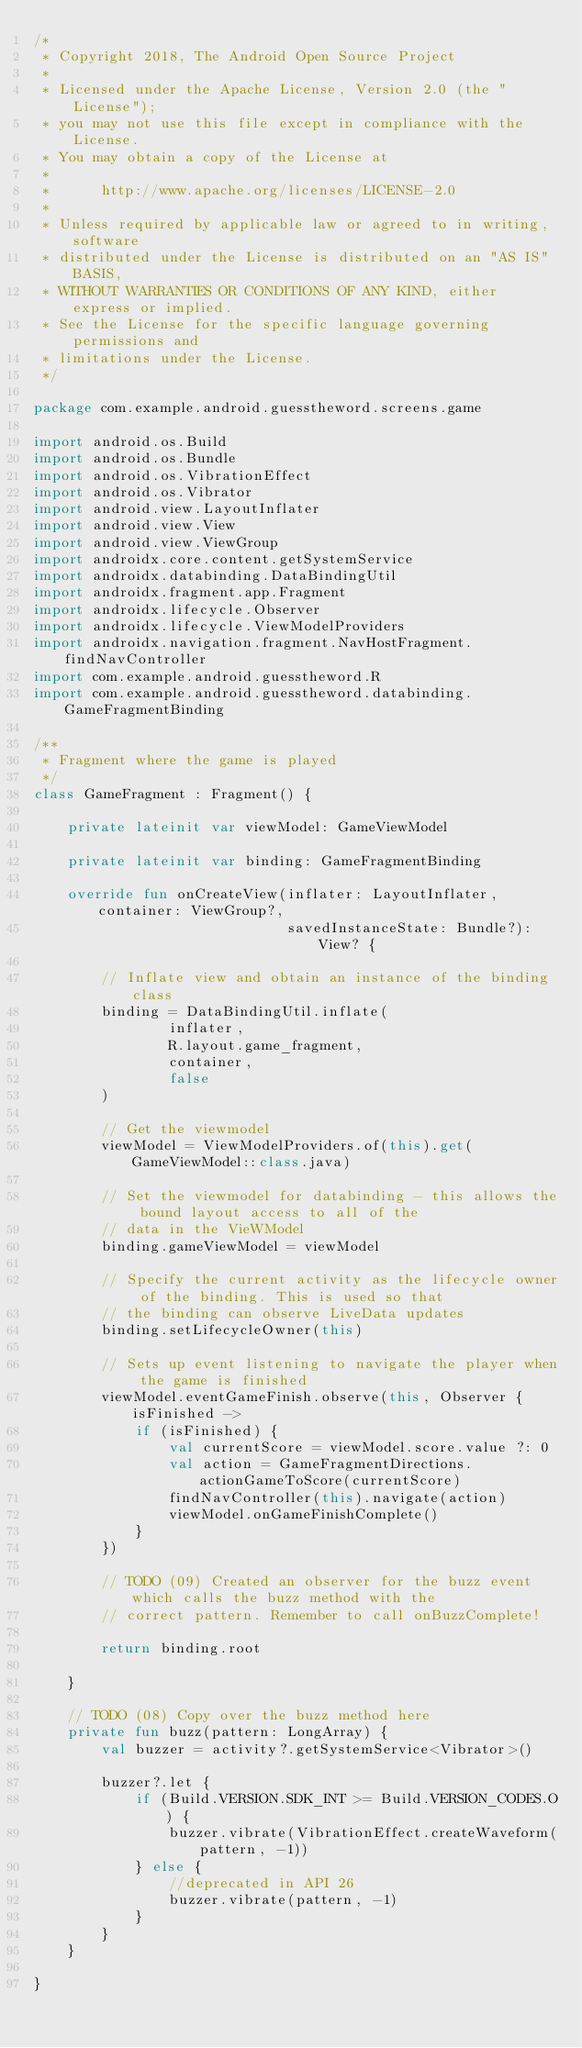<code> <loc_0><loc_0><loc_500><loc_500><_Kotlin_>/*
 * Copyright 2018, The Android Open Source Project
 *
 * Licensed under the Apache License, Version 2.0 (the "License");
 * you may not use this file except in compliance with the License.
 * You may obtain a copy of the License at
 *
 *      http://www.apache.org/licenses/LICENSE-2.0
 *
 * Unless required by applicable law or agreed to in writing, software
 * distributed under the License is distributed on an "AS IS" BASIS,
 * WITHOUT WARRANTIES OR CONDITIONS OF ANY KIND, either express or implied.
 * See the License for the specific language governing permissions and
 * limitations under the License.
 */

package com.example.android.guesstheword.screens.game

import android.os.Build
import android.os.Bundle
import android.os.VibrationEffect
import android.os.Vibrator
import android.view.LayoutInflater
import android.view.View
import android.view.ViewGroup
import androidx.core.content.getSystemService
import androidx.databinding.DataBindingUtil
import androidx.fragment.app.Fragment
import androidx.lifecycle.Observer
import androidx.lifecycle.ViewModelProviders
import androidx.navigation.fragment.NavHostFragment.findNavController
import com.example.android.guesstheword.R
import com.example.android.guesstheword.databinding.GameFragmentBinding

/**
 * Fragment where the game is played
 */
class GameFragment : Fragment() {

    private lateinit var viewModel: GameViewModel

    private lateinit var binding: GameFragmentBinding

    override fun onCreateView(inflater: LayoutInflater, container: ViewGroup?,
                              savedInstanceState: Bundle?): View? {

        // Inflate view and obtain an instance of the binding class
        binding = DataBindingUtil.inflate(
                inflater,
                R.layout.game_fragment,
                container,
                false
        )

        // Get the viewmodel
        viewModel = ViewModelProviders.of(this).get(GameViewModel::class.java)

        // Set the viewmodel for databinding - this allows the bound layout access to all of the
        // data in the VieWModel
        binding.gameViewModel = viewModel

        // Specify the current activity as the lifecycle owner of the binding. This is used so that
        // the binding can observe LiveData updates
        binding.setLifecycleOwner(this)

        // Sets up event listening to navigate the player when the game is finished
        viewModel.eventGameFinish.observe(this, Observer { isFinished ->
            if (isFinished) {
                val currentScore = viewModel.score.value ?: 0
                val action = GameFragmentDirections.actionGameToScore(currentScore)
                findNavController(this).navigate(action)
                viewModel.onGameFinishComplete()
            }
        })

        // TODO (09) Created an observer for the buzz event which calls the buzz method with the
        // correct pattern. Remember to call onBuzzComplete!

        return binding.root

    }

    // TODO (08) Copy over the buzz method here
    private fun buzz(pattern: LongArray) {
        val buzzer = activity?.getSystemService<Vibrator>()

        buzzer?.let {
            if (Build.VERSION.SDK_INT >= Build.VERSION_CODES.O) {
                buzzer.vibrate(VibrationEffect.createWaveform(pattern, -1))
            } else {
                //deprecated in API 26
                buzzer.vibrate(pattern, -1)
            }
        }
    }

}
</code> 